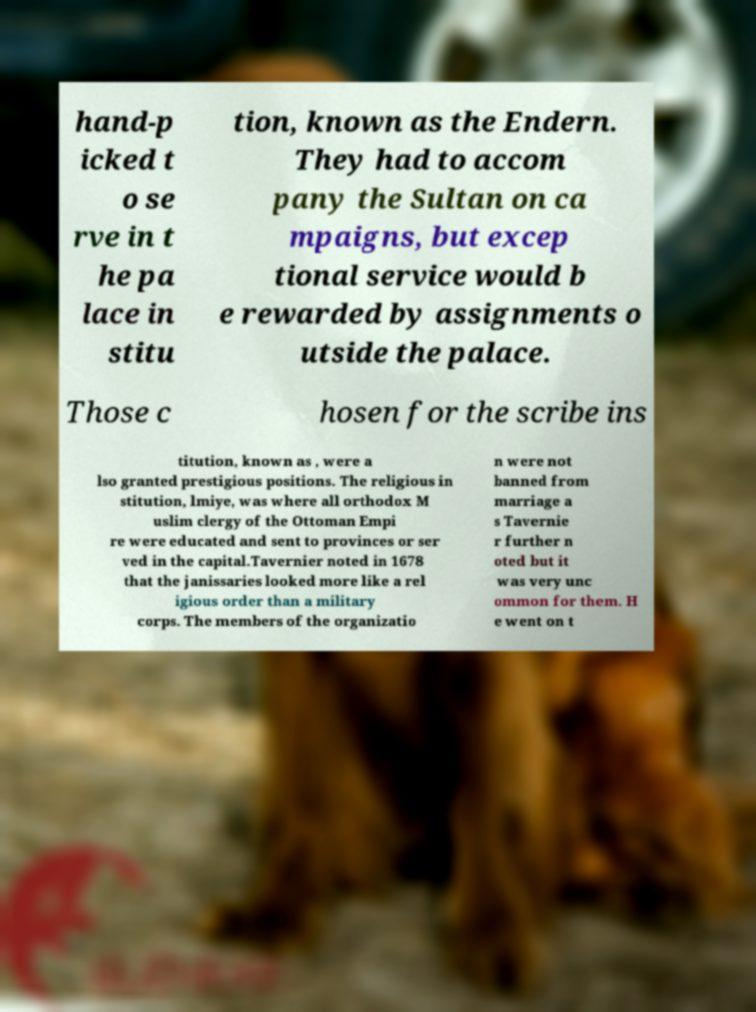What messages or text are displayed in this image? I need them in a readable, typed format. hand-p icked t o se rve in t he pa lace in stitu tion, known as the Endern. They had to accom pany the Sultan on ca mpaigns, but excep tional service would b e rewarded by assignments o utside the palace. Those c hosen for the scribe ins titution, known as , were a lso granted prestigious positions. The religious in stitution, lmiye, was where all orthodox M uslim clergy of the Ottoman Empi re were educated and sent to provinces or ser ved in the capital.Tavernier noted in 1678 that the janissaries looked more like a rel igious order than a military corps. The members of the organizatio n were not banned from marriage a s Tavernie r further n oted but it was very unc ommon for them. H e went on t 